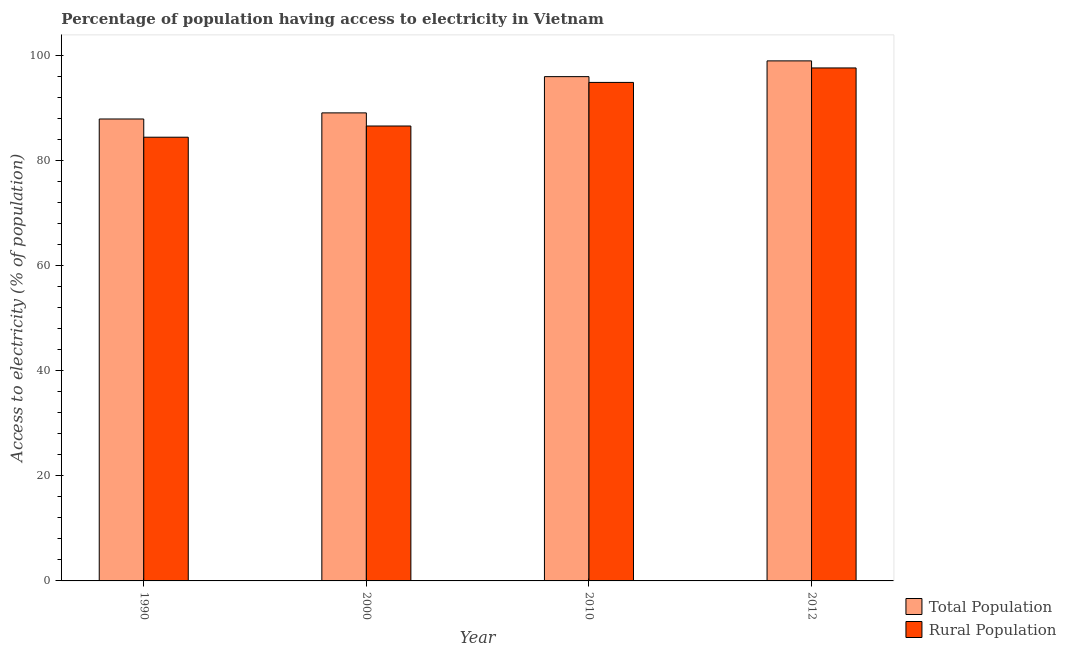Are the number of bars per tick equal to the number of legend labels?
Your answer should be compact. Yes. Are the number of bars on each tick of the X-axis equal?
Give a very brief answer. Yes. How many bars are there on the 4th tick from the right?
Offer a terse response. 2. What is the label of the 1st group of bars from the left?
Provide a short and direct response. 1990. What is the percentage of rural population having access to electricity in 2012?
Make the answer very short. 97.65. Across all years, what is the maximum percentage of rural population having access to electricity?
Provide a succinct answer. 97.65. Across all years, what is the minimum percentage of population having access to electricity?
Provide a short and direct response. 87.94. What is the total percentage of population having access to electricity in the graph?
Make the answer very short. 372.04. What is the difference between the percentage of rural population having access to electricity in 2010 and that in 2012?
Provide a succinct answer. -2.75. What is the difference between the percentage of population having access to electricity in 1990 and the percentage of rural population having access to electricity in 2000?
Your answer should be very brief. -1.16. What is the average percentage of rural population having access to electricity per year?
Provide a succinct answer. 90.91. In the year 2000, what is the difference between the percentage of rural population having access to electricity and percentage of population having access to electricity?
Offer a very short reply. 0. What is the ratio of the percentage of population having access to electricity in 1990 to that in 2010?
Provide a short and direct response. 0.92. Is the percentage of rural population having access to electricity in 2000 less than that in 2012?
Provide a short and direct response. Yes. What is the difference between the highest and the second highest percentage of rural population having access to electricity?
Offer a terse response. 2.75. What is the difference between the highest and the lowest percentage of population having access to electricity?
Offer a very short reply. 11.06. In how many years, is the percentage of rural population having access to electricity greater than the average percentage of rural population having access to electricity taken over all years?
Provide a succinct answer. 2. Is the sum of the percentage of population having access to electricity in 2000 and 2012 greater than the maximum percentage of rural population having access to electricity across all years?
Your answer should be very brief. Yes. What does the 2nd bar from the left in 2000 represents?
Give a very brief answer. Rural Population. What does the 2nd bar from the right in 2012 represents?
Provide a succinct answer. Total Population. How many bars are there?
Provide a short and direct response. 8. How many years are there in the graph?
Keep it short and to the point. 4. What is the difference between two consecutive major ticks on the Y-axis?
Provide a succinct answer. 20. Does the graph contain grids?
Ensure brevity in your answer.  No. Where does the legend appear in the graph?
Offer a very short reply. Bottom right. How are the legend labels stacked?
Provide a succinct answer. Vertical. What is the title of the graph?
Offer a very short reply. Percentage of population having access to electricity in Vietnam. Does "Number of departures" appear as one of the legend labels in the graph?
Your answer should be very brief. No. What is the label or title of the Y-axis?
Provide a succinct answer. Access to electricity (% of population). What is the Access to electricity (% of population) of Total Population in 1990?
Your answer should be very brief. 87.94. What is the Access to electricity (% of population) in Rural Population in 1990?
Make the answer very short. 84.47. What is the Access to electricity (% of population) of Total Population in 2000?
Offer a very short reply. 89.1. What is the Access to electricity (% of population) of Rural Population in 2000?
Keep it short and to the point. 86.6. What is the Access to electricity (% of population) in Total Population in 2010?
Keep it short and to the point. 96. What is the Access to electricity (% of population) of Rural Population in 2010?
Make the answer very short. 94.9. What is the Access to electricity (% of population) of Rural Population in 2012?
Your answer should be compact. 97.65. Across all years, what is the maximum Access to electricity (% of population) of Total Population?
Provide a short and direct response. 99. Across all years, what is the maximum Access to electricity (% of population) in Rural Population?
Give a very brief answer. 97.65. Across all years, what is the minimum Access to electricity (% of population) in Total Population?
Provide a succinct answer. 87.94. Across all years, what is the minimum Access to electricity (% of population) of Rural Population?
Offer a terse response. 84.47. What is the total Access to electricity (% of population) in Total Population in the graph?
Ensure brevity in your answer.  372.04. What is the total Access to electricity (% of population) of Rural Population in the graph?
Make the answer very short. 363.62. What is the difference between the Access to electricity (% of population) in Total Population in 1990 and that in 2000?
Provide a succinct answer. -1.16. What is the difference between the Access to electricity (% of population) in Rural Population in 1990 and that in 2000?
Offer a very short reply. -2.13. What is the difference between the Access to electricity (% of population) in Total Population in 1990 and that in 2010?
Your response must be concise. -8.06. What is the difference between the Access to electricity (% of population) of Rural Population in 1990 and that in 2010?
Your response must be concise. -10.43. What is the difference between the Access to electricity (% of population) of Total Population in 1990 and that in 2012?
Give a very brief answer. -11.06. What is the difference between the Access to electricity (% of population) in Rural Population in 1990 and that in 2012?
Your answer should be compact. -13.18. What is the difference between the Access to electricity (% of population) of Total Population in 2000 and that in 2010?
Ensure brevity in your answer.  -6.9. What is the difference between the Access to electricity (% of population) in Total Population in 2000 and that in 2012?
Your response must be concise. -9.9. What is the difference between the Access to electricity (% of population) in Rural Population in 2000 and that in 2012?
Your response must be concise. -11.05. What is the difference between the Access to electricity (% of population) of Total Population in 2010 and that in 2012?
Your response must be concise. -3. What is the difference between the Access to electricity (% of population) in Rural Population in 2010 and that in 2012?
Offer a terse response. -2.75. What is the difference between the Access to electricity (% of population) of Total Population in 1990 and the Access to electricity (% of population) of Rural Population in 2000?
Provide a short and direct response. 1.34. What is the difference between the Access to electricity (% of population) of Total Population in 1990 and the Access to electricity (% of population) of Rural Population in 2010?
Ensure brevity in your answer.  -6.96. What is the difference between the Access to electricity (% of population) of Total Population in 1990 and the Access to electricity (% of population) of Rural Population in 2012?
Give a very brief answer. -9.72. What is the difference between the Access to electricity (% of population) of Total Population in 2000 and the Access to electricity (% of population) of Rural Population in 2010?
Provide a short and direct response. -5.8. What is the difference between the Access to electricity (% of population) in Total Population in 2000 and the Access to electricity (% of population) in Rural Population in 2012?
Your answer should be very brief. -8.55. What is the difference between the Access to electricity (% of population) in Total Population in 2010 and the Access to electricity (% of population) in Rural Population in 2012?
Your response must be concise. -1.65. What is the average Access to electricity (% of population) in Total Population per year?
Provide a succinct answer. 93.01. What is the average Access to electricity (% of population) of Rural Population per year?
Give a very brief answer. 90.91. In the year 1990, what is the difference between the Access to electricity (% of population) in Total Population and Access to electricity (% of population) in Rural Population?
Your answer should be very brief. 3.47. In the year 2010, what is the difference between the Access to electricity (% of population) of Total Population and Access to electricity (% of population) of Rural Population?
Offer a terse response. 1.1. In the year 2012, what is the difference between the Access to electricity (% of population) in Total Population and Access to electricity (% of population) in Rural Population?
Make the answer very short. 1.35. What is the ratio of the Access to electricity (% of population) of Total Population in 1990 to that in 2000?
Your answer should be compact. 0.99. What is the ratio of the Access to electricity (% of population) in Rural Population in 1990 to that in 2000?
Make the answer very short. 0.98. What is the ratio of the Access to electricity (% of population) in Total Population in 1990 to that in 2010?
Your answer should be very brief. 0.92. What is the ratio of the Access to electricity (% of population) of Rural Population in 1990 to that in 2010?
Provide a short and direct response. 0.89. What is the ratio of the Access to electricity (% of population) in Total Population in 1990 to that in 2012?
Offer a very short reply. 0.89. What is the ratio of the Access to electricity (% of population) of Rural Population in 1990 to that in 2012?
Keep it short and to the point. 0.86. What is the ratio of the Access to electricity (% of population) in Total Population in 2000 to that in 2010?
Give a very brief answer. 0.93. What is the ratio of the Access to electricity (% of population) in Rural Population in 2000 to that in 2010?
Provide a succinct answer. 0.91. What is the ratio of the Access to electricity (% of population) in Rural Population in 2000 to that in 2012?
Provide a succinct answer. 0.89. What is the ratio of the Access to electricity (% of population) in Total Population in 2010 to that in 2012?
Make the answer very short. 0.97. What is the ratio of the Access to electricity (% of population) of Rural Population in 2010 to that in 2012?
Your answer should be very brief. 0.97. What is the difference between the highest and the second highest Access to electricity (% of population) of Total Population?
Your answer should be very brief. 3. What is the difference between the highest and the second highest Access to electricity (% of population) in Rural Population?
Your answer should be compact. 2.75. What is the difference between the highest and the lowest Access to electricity (% of population) of Total Population?
Give a very brief answer. 11.06. What is the difference between the highest and the lowest Access to electricity (% of population) of Rural Population?
Your answer should be very brief. 13.18. 